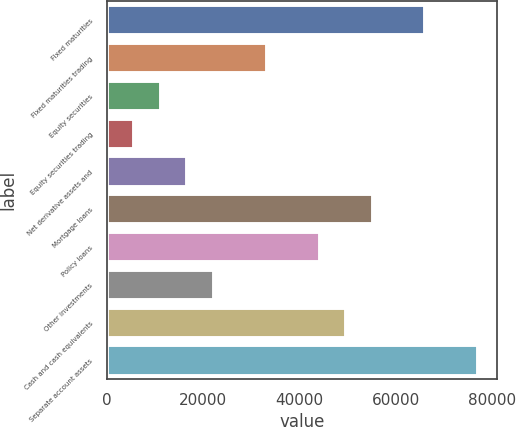Convert chart. <chart><loc_0><loc_0><loc_500><loc_500><bar_chart><fcel>Fixed maturities<fcel>Fixed maturities trading<fcel>Equity securities<fcel>Equity securities trading<fcel>Net derivative assets and<fcel>Mortgage loans<fcel>Policy loans<fcel>Other investments<fcel>Cash and cash equivalents<fcel>Separate account assets<nl><fcel>66149.3<fcel>33129.3<fcel>11116<fcel>5612.63<fcel>16619.3<fcel>55142.6<fcel>44135.9<fcel>22122.6<fcel>49639.3<fcel>77155.9<nl></chart> 